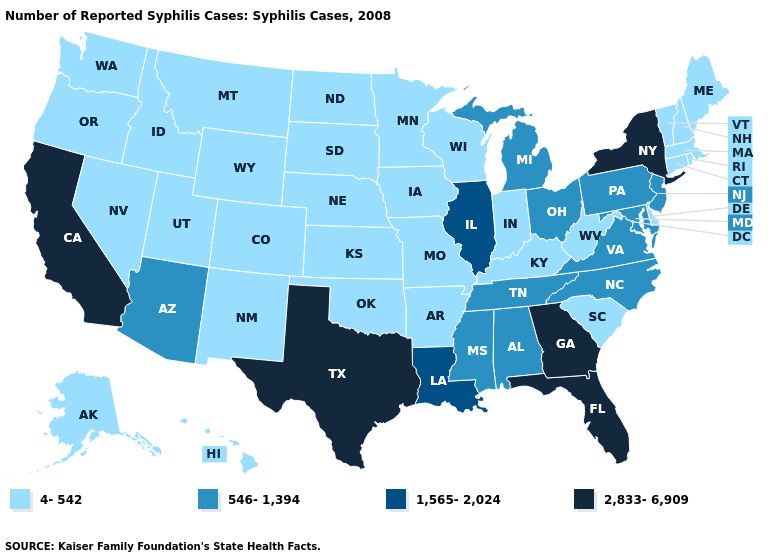Does Louisiana have the lowest value in the USA?
Concise answer only. No. Which states hav the highest value in the Northeast?
Give a very brief answer. New York. Name the states that have a value in the range 546-1,394?
Keep it brief. Alabama, Arizona, Maryland, Michigan, Mississippi, New Jersey, North Carolina, Ohio, Pennsylvania, Tennessee, Virginia. Does Pennsylvania have a lower value than New York?
Concise answer only. Yes. What is the value of Washington?
Write a very short answer. 4-542. What is the lowest value in states that border South Dakota?
Concise answer only. 4-542. What is the value of Alabama?
Short answer required. 546-1,394. Name the states that have a value in the range 2,833-6,909?
Concise answer only. California, Florida, Georgia, New York, Texas. What is the value of Michigan?
Quick response, please. 546-1,394. What is the lowest value in the West?
Keep it brief. 4-542. What is the value of Montana?
Give a very brief answer. 4-542. Among the states that border South Dakota , which have the highest value?
Short answer required. Iowa, Minnesota, Montana, Nebraska, North Dakota, Wyoming. Is the legend a continuous bar?
Concise answer only. No. What is the highest value in states that border Kentucky?
Quick response, please. 1,565-2,024. Does Oklahoma have a higher value than South Carolina?
Answer briefly. No. 